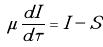<formula> <loc_0><loc_0><loc_500><loc_500>\mu \frac { d I } { d \tau } = I - S</formula> 